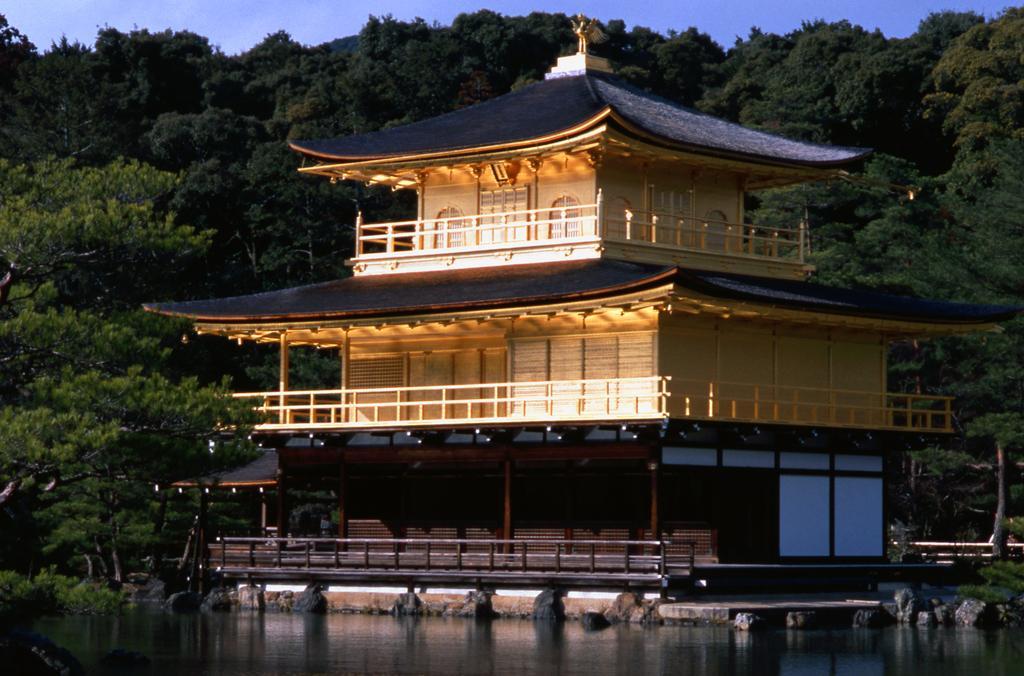How would you summarize this image in a sentence or two? This is the picture of a building. In the foreground there is a building. At the back there are trees. At the top there is sky. At the bottom there is water. There is a sculpture on the top of the building. 